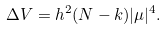<formula> <loc_0><loc_0><loc_500><loc_500>\Delta V = h ^ { 2 } ( N - k ) | \mu | ^ { 4 } .</formula> 